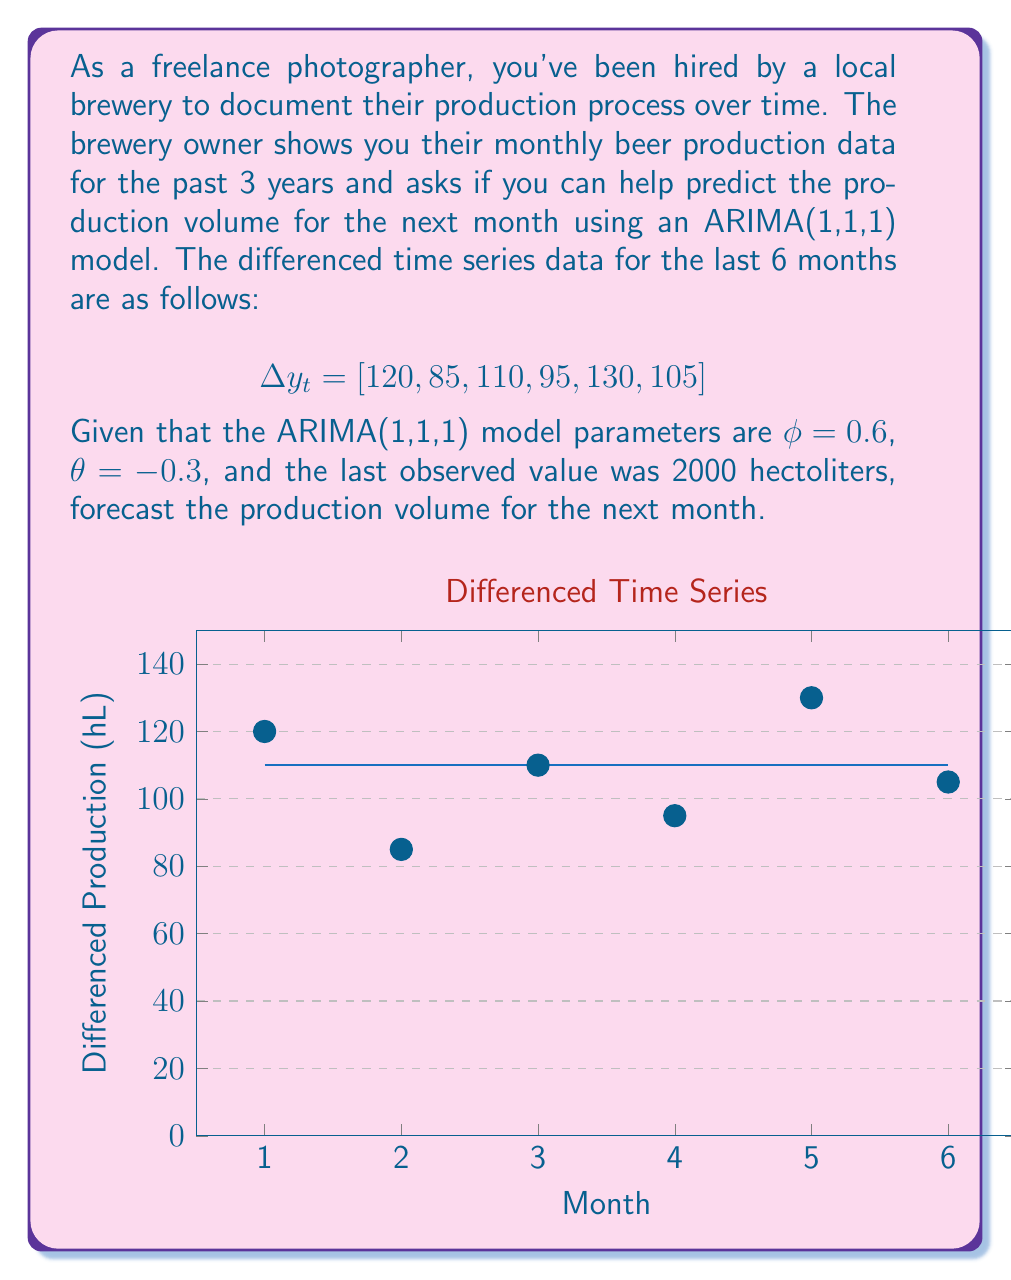Show me your answer to this math problem. To forecast the production volume using the ARIMA(1,1,1) model, we'll follow these steps:

1) The general form of an ARIMA(1,1,1) model is:

   $$(1-\phi B)(1-B)y_t = (1+\theta B)\epsilon_t$$

   where $B$ is the backshift operator.

2) For forecasting one step ahead, we use the equation:

   $$\hat{y}_{t+1} = y_t + \phi(y_t - y_{t-1}) - \theta\epsilon_t$$

3) We need to calculate $\epsilon_t$, which is the forecast error for the current period:

   $$\epsilon_t = \Delta y_t - \phi \Delta y_{t-1} + \theta \epsilon_{t-1}$$

4) Using the given data, we can calculate:
   
   $\Delta y_t = 105$
   $\Delta y_{t-1} = 130$

5) We don't know $\epsilon_{t-1}$, but for forecasting purposes, we can assume it's zero.

6) Now we can calculate $\epsilon_t$:

   $$\epsilon_t = 105 - 0.6(130) + 0 = 27$$

7) Using the forecasting equation:

   $$\hat{y}_{t+1} = 2000 + 0.6(105) - (-0.3)(27) = 2071.1$$

Therefore, the forecast for the next month's production is approximately 2071 hectoliters.
Answer: 2071 hectoliters 